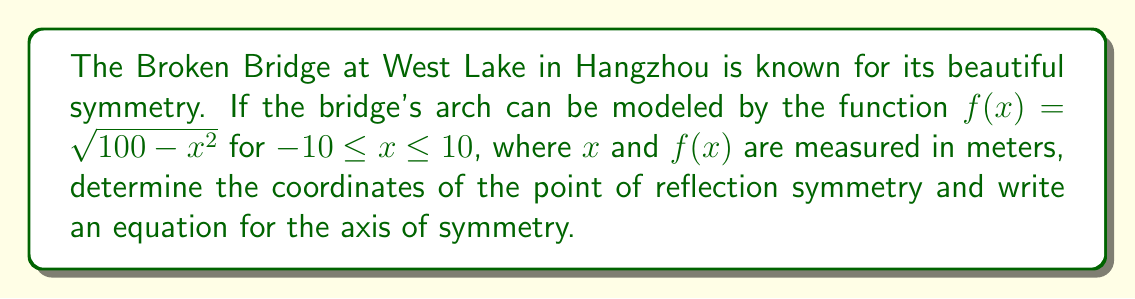Give your solution to this math problem. Let's approach this step-by-step:

1) The function $f(x)=\sqrt{100-x^2}$ represents the upper half of a circle centered at (0,0) with a radius of 10 meters.

2) For a circle, the axis of symmetry is the vertical line that passes through its center.

3) The center of this circle is at (0,0), so the axis of symmetry is the y-axis, which has the equation $x=0$.

4) The point of reflection symmetry is the highest point on the bridge, which occurs at the center of the arch.

5) To find the y-coordinate of this point, we can evaluate $f(x)$ at $x=0$:

   $f(0) = \sqrt{100-0^2} = \sqrt{100} = 10$

6) Therefore, the point of reflection symmetry is (0,10).

[asy]
import graph;
size(200);
xaxis("x",-10,10,Arrow);
yaxis("y",0,12,Arrow);
draw((-10,0)--(10,0),blue);
draw(arc((0,0),10,180,0),blue+1);
dot((0,10),red);
label("(0,10)",(0,10),N);
[/asy]
Answer: Point of reflection symmetry: (0,10); Axis of symmetry: $x=0$ 